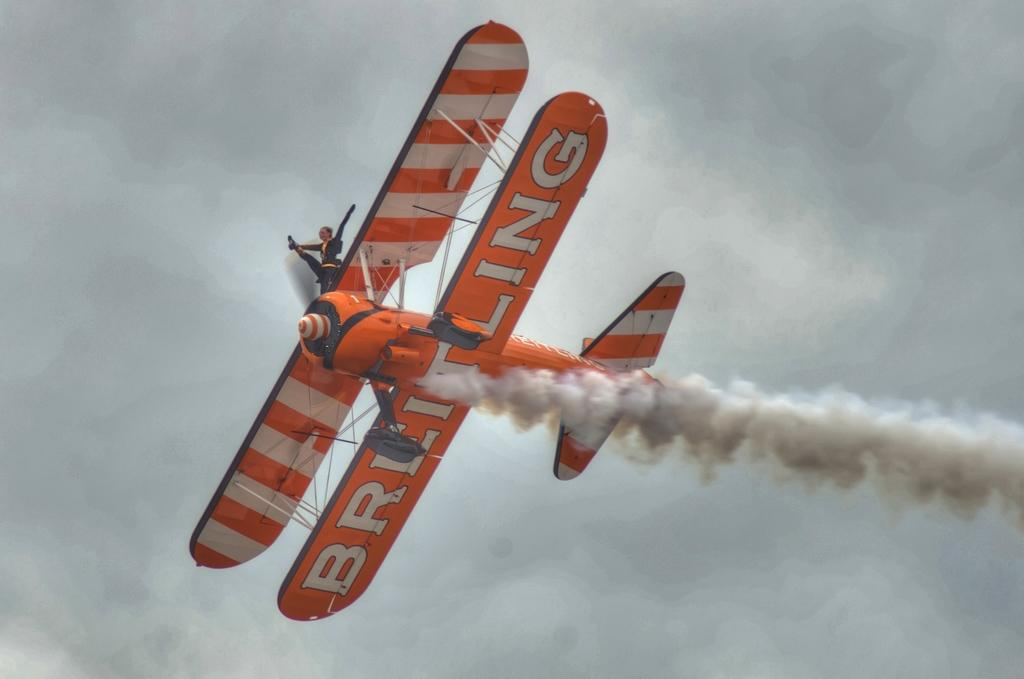Provide a one-sentence caption for the provided image. A daredevil performs a trick on top of a prop airplane. 